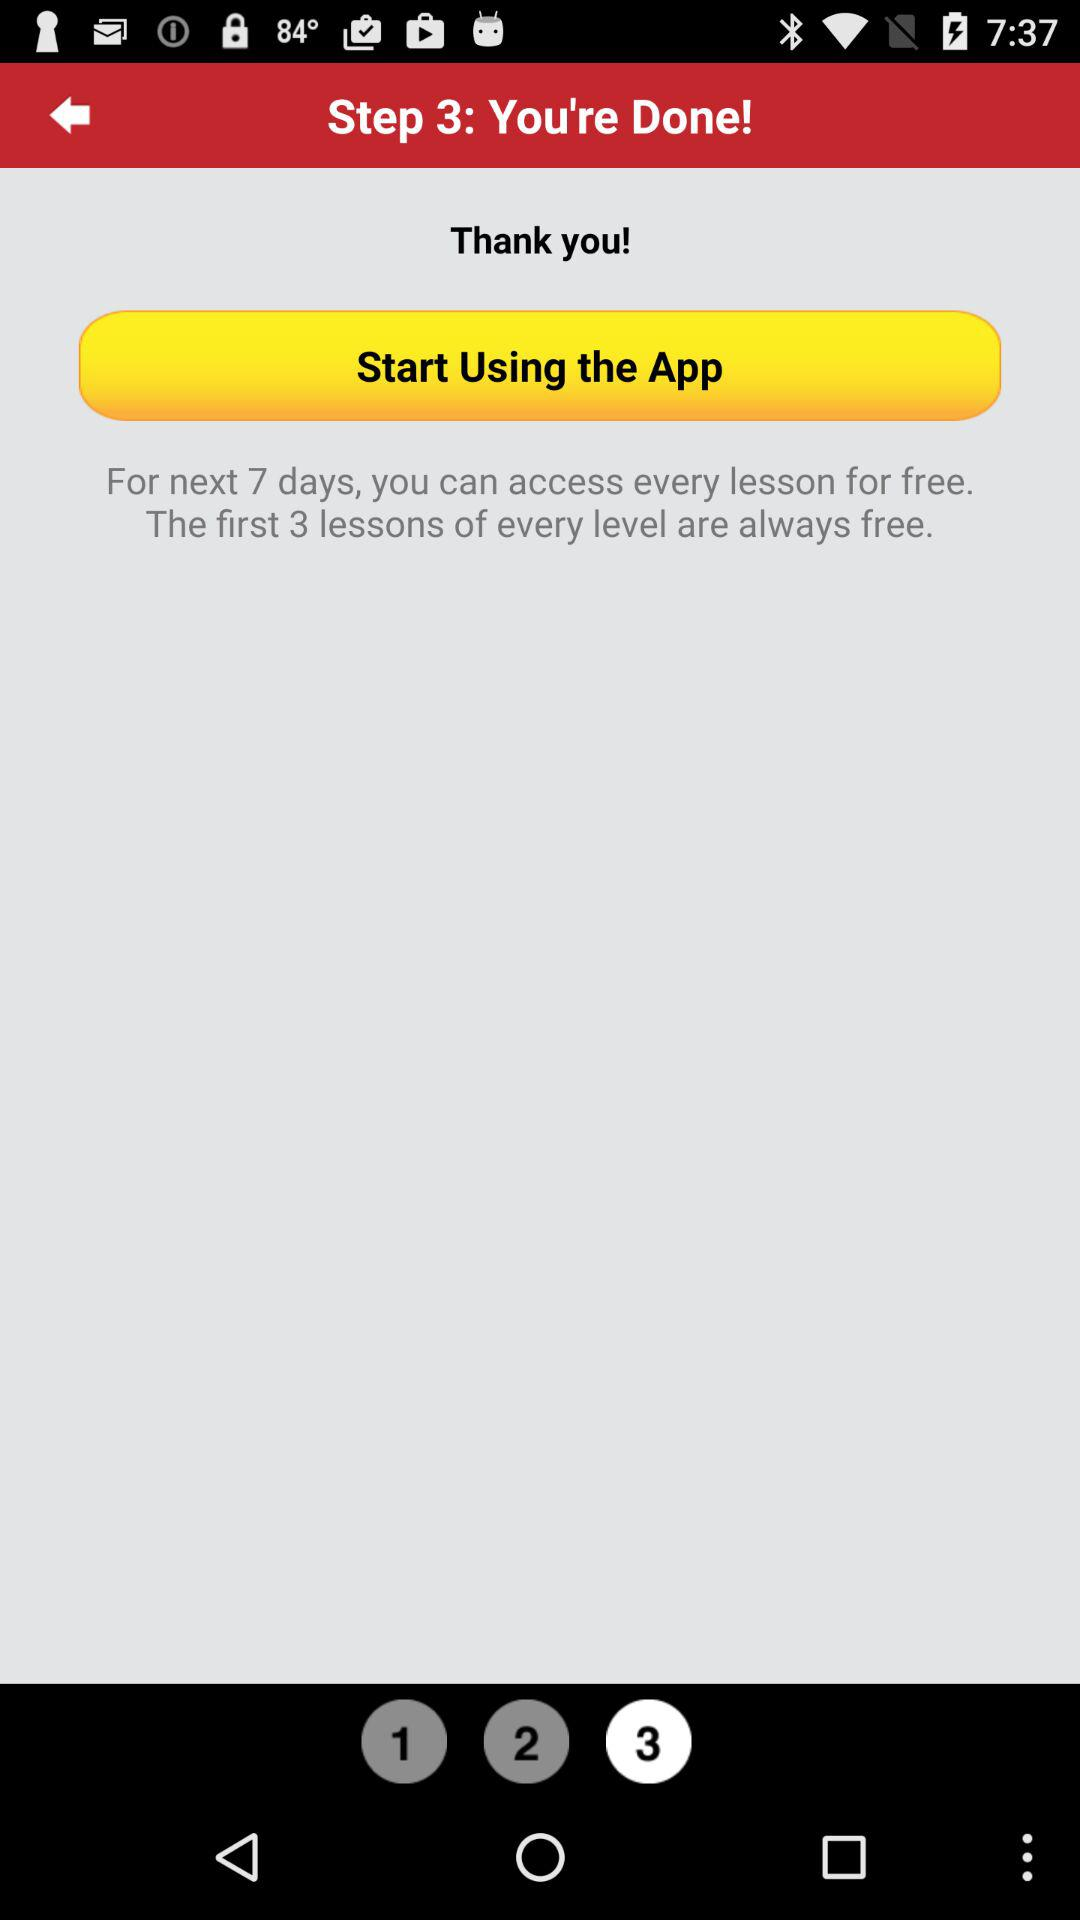What is the number of steps? The number of steps is 3. 